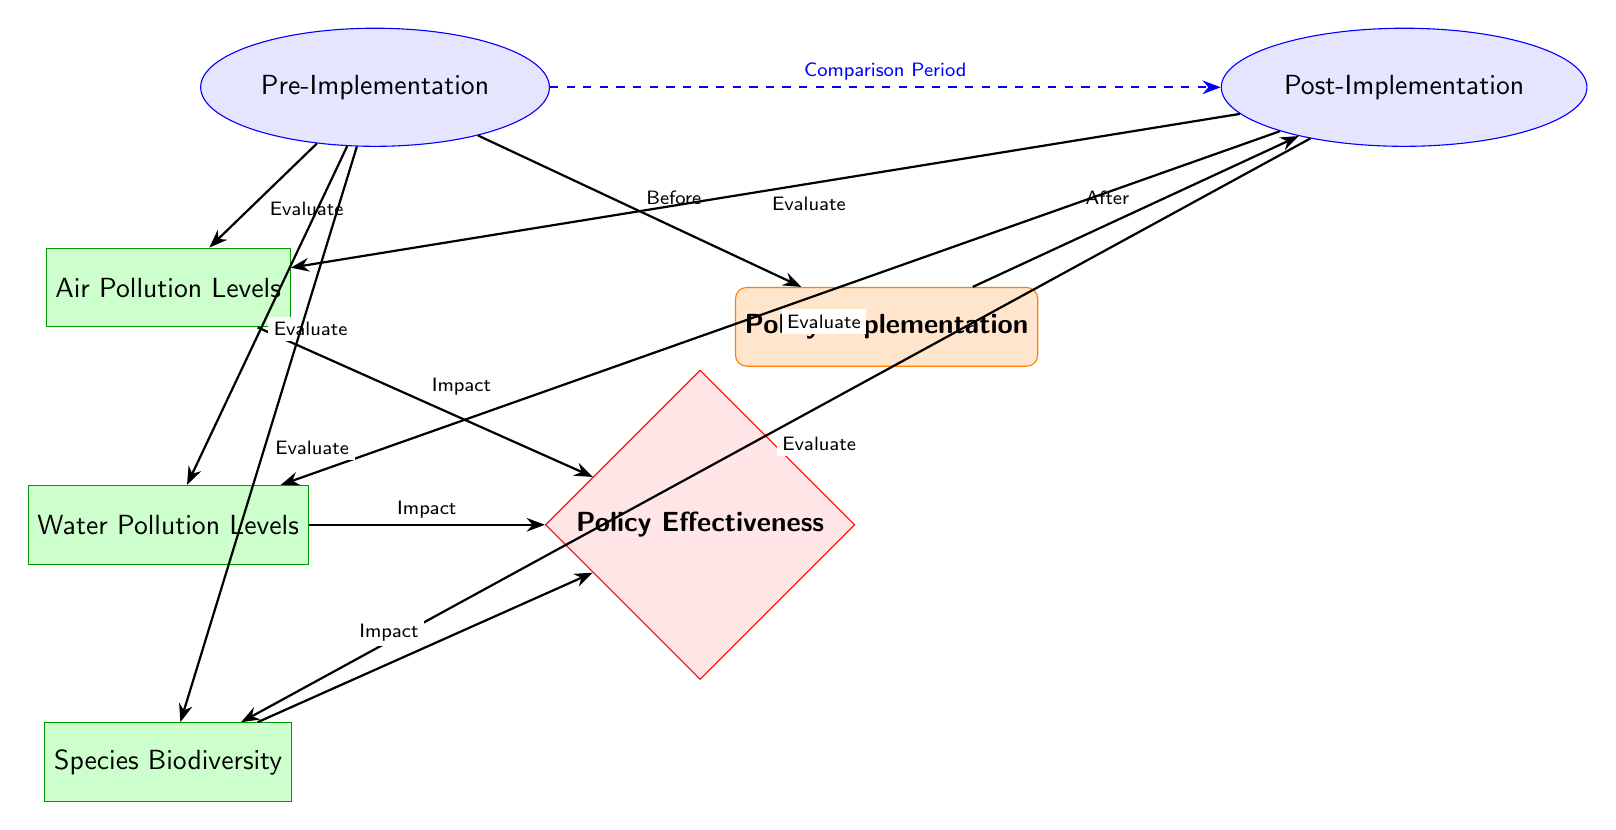What is the first node in the diagram? The first node in the diagram, positioned at the center as the starting point, is "Policy Implementation".
Answer: Policy Implementation How many time frames are present in the diagram? There are two time frames represented in the diagram: "Pre-Implementation" and "Post-Implementation".
Answer: 2 What color is used for the outcome node? The outcome node is represented by the color red, specifically with a red fill and border for the "Policy Effectiveness" label.
Answer: Red What metric is directly connected to air pollution evaluation? The metric "Air Pollution Levels" is directly connected to the evaluation arrows coming from the "Pre-Implementation" and "Post-Implementation" nodes.
Answer: Air Pollution Levels Which node indicates a comparison period? The dashed blue arrow indicates a comparison period between the "Pre-Implementation" and "Post-Implementation" time frames, labeled as "Comparison Period".
Answer: Comparison Period What is the relationship between "Water Pollution Levels" and "Policy Effectiveness"? The relationship is direct, as there is an arrow labeled "Impact" leading from "Water Pollution Levels" to "Policy Effectiveness", indicating that water pollution impacts the effectiveness of the policy.
Answer: Impact Which time frame contains the metric "Species Biodiversity"? "Species Biodiversity" is located in the "Pre-Implementation" time frame, as indicated by its placement below the corresponding time frame node.
Answer: Pre-Implementation What is the last step in the evaluation process for water pollution? The last step in the evaluation process for water pollution is captured by the arrow labeled "Impact" which points from "Water Pollution Levels" to "Policy Effectiveness".
Answer: Impact How many metrics are evaluated in this diagram? The diagram includes three metrics that are evaluated: "Air Pollution Levels", "Water Pollution Levels", and "Species Biodiversity".
Answer: 3 